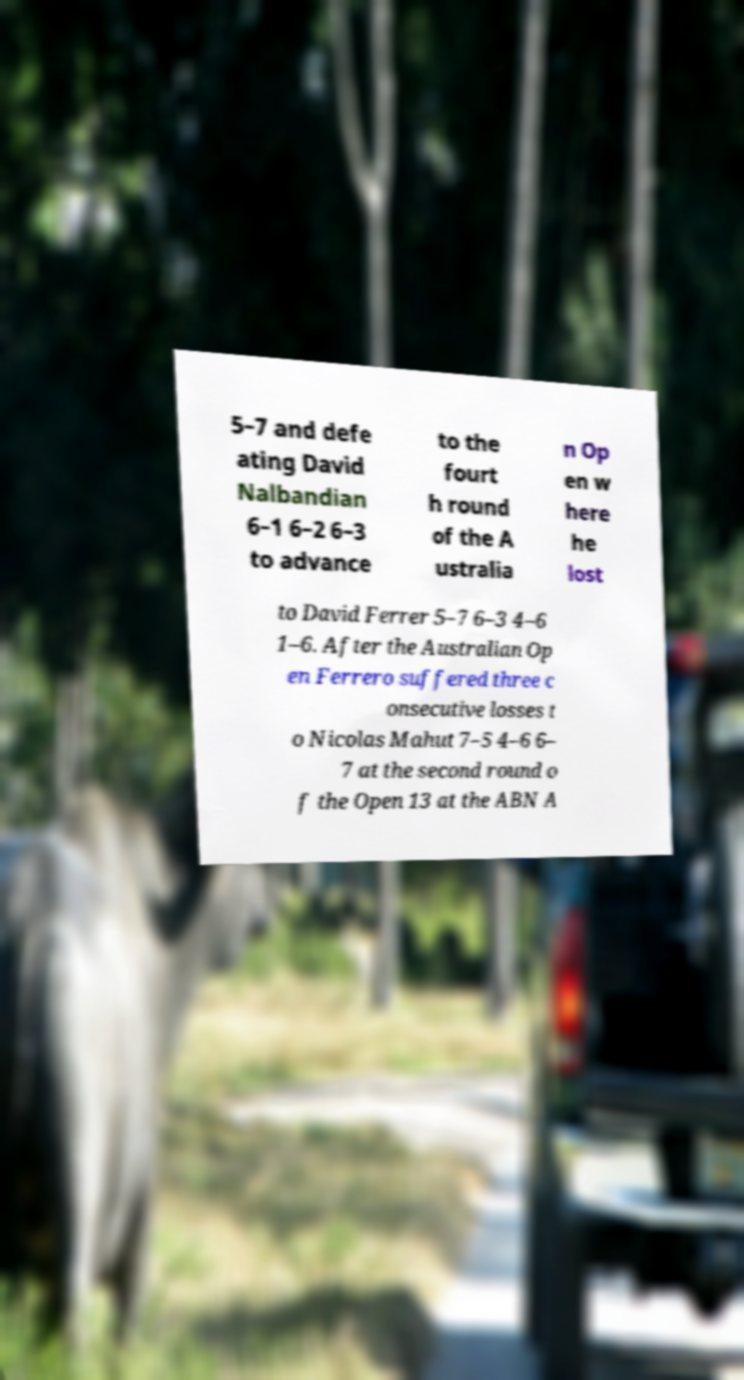There's text embedded in this image that I need extracted. Can you transcribe it verbatim? 5–7 and defe ating David Nalbandian 6–1 6–2 6–3 to advance to the fourt h round of the A ustralia n Op en w here he lost to David Ferrer 5–7 6–3 4–6 1–6. After the Australian Op en Ferrero suffered three c onsecutive losses t o Nicolas Mahut 7–5 4–6 6– 7 at the second round o f the Open 13 at the ABN A 